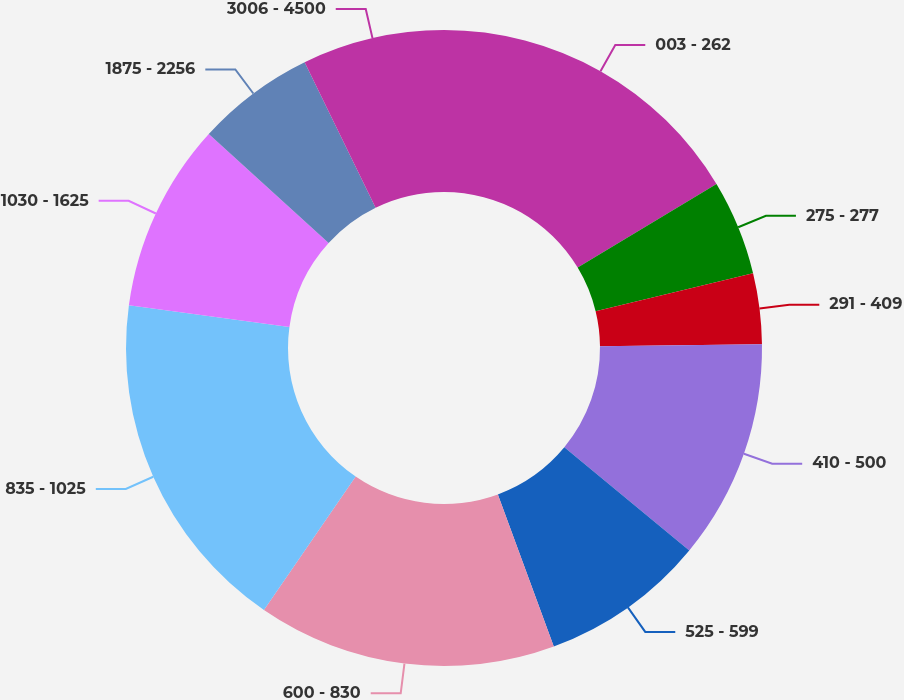Convert chart to OTSL. <chart><loc_0><loc_0><loc_500><loc_500><pie_chart><fcel>003 - 262<fcel>275 - 277<fcel>291 - 409<fcel>410 - 500<fcel>525 - 599<fcel>600 - 830<fcel>835 - 1025<fcel>1030 - 1625<fcel>1875 - 2256<fcel>3006 - 4500<nl><fcel>16.38%<fcel>4.84%<fcel>3.59%<fcel>11.17%<fcel>8.41%<fcel>15.19%<fcel>17.57%<fcel>9.6%<fcel>6.03%<fcel>7.22%<nl></chart> 